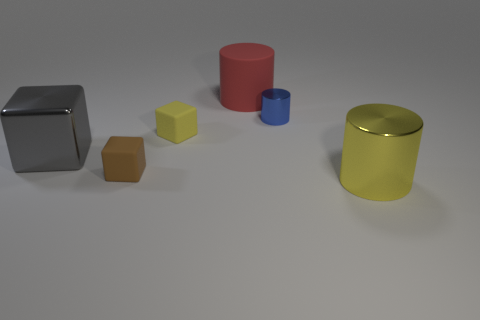Are there an equal number of yellow shiny things in front of the small shiny cylinder and small yellow objects in front of the large gray metallic object?
Your answer should be compact. No. How many balls are either small matte things or big red things?
Offer a very short reply. 0. What is the shape of the big metal object right of the blue object?
Offer a terse response. Cylinder. There is a tiny thing that is to the left of the yellow thing behind the metal cube; what is it made of?
Give a very brief answer. Rubber. Is the number of yellow blocks to the left of the small brown rubber object greater than the number of metallic cubes?
Offer a very short reply. No. How many other things are the same color as the metallic block?
Make the answer very short. 0. The gray shiny object that is the same size as the red rubber object is what shape?
Provide a succinct answer. Cube. How many blue things are in front of the yellow cylinder in front of the large red matte cylinder that is right of the tiny yellow cube?
Provide a short and direct response. 0. What number of matte objects are either red blocks or blue cylinders?
Keep it short and to the point. 0. There is a big object that is both to the right of the tiny brown rubber cube and to the left of the tiny blue metal object; what is its color?
Provide a succinct answer. Red. 